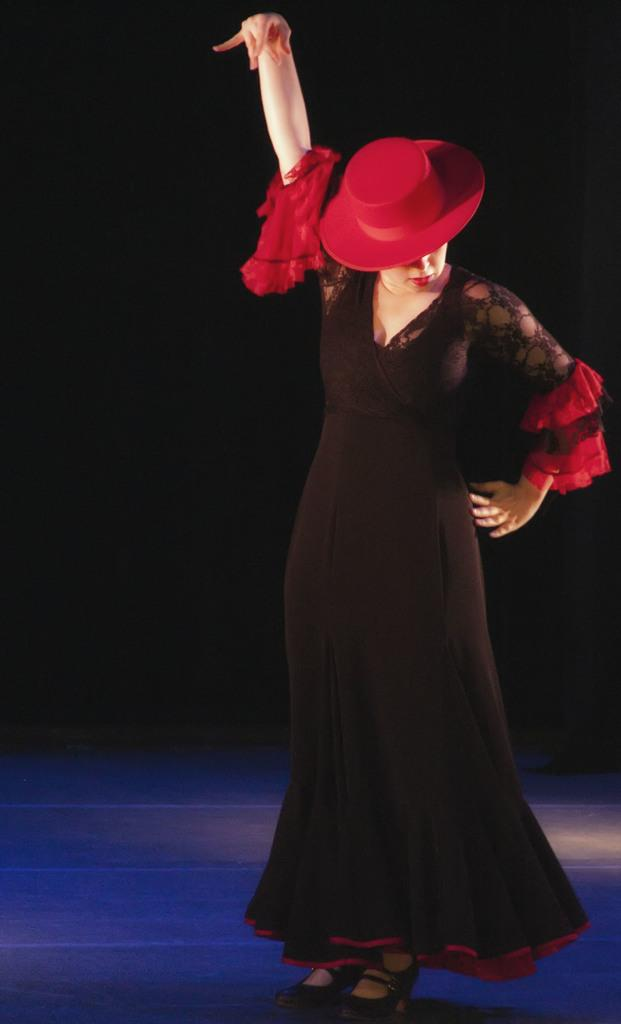Who is present in the image? There is a woman in the image. What is the woman doing in the image? The woman is standing on the floor. What type of memory does the woman have in the image? There is no mention of a memory or any object related to memory in the image. 